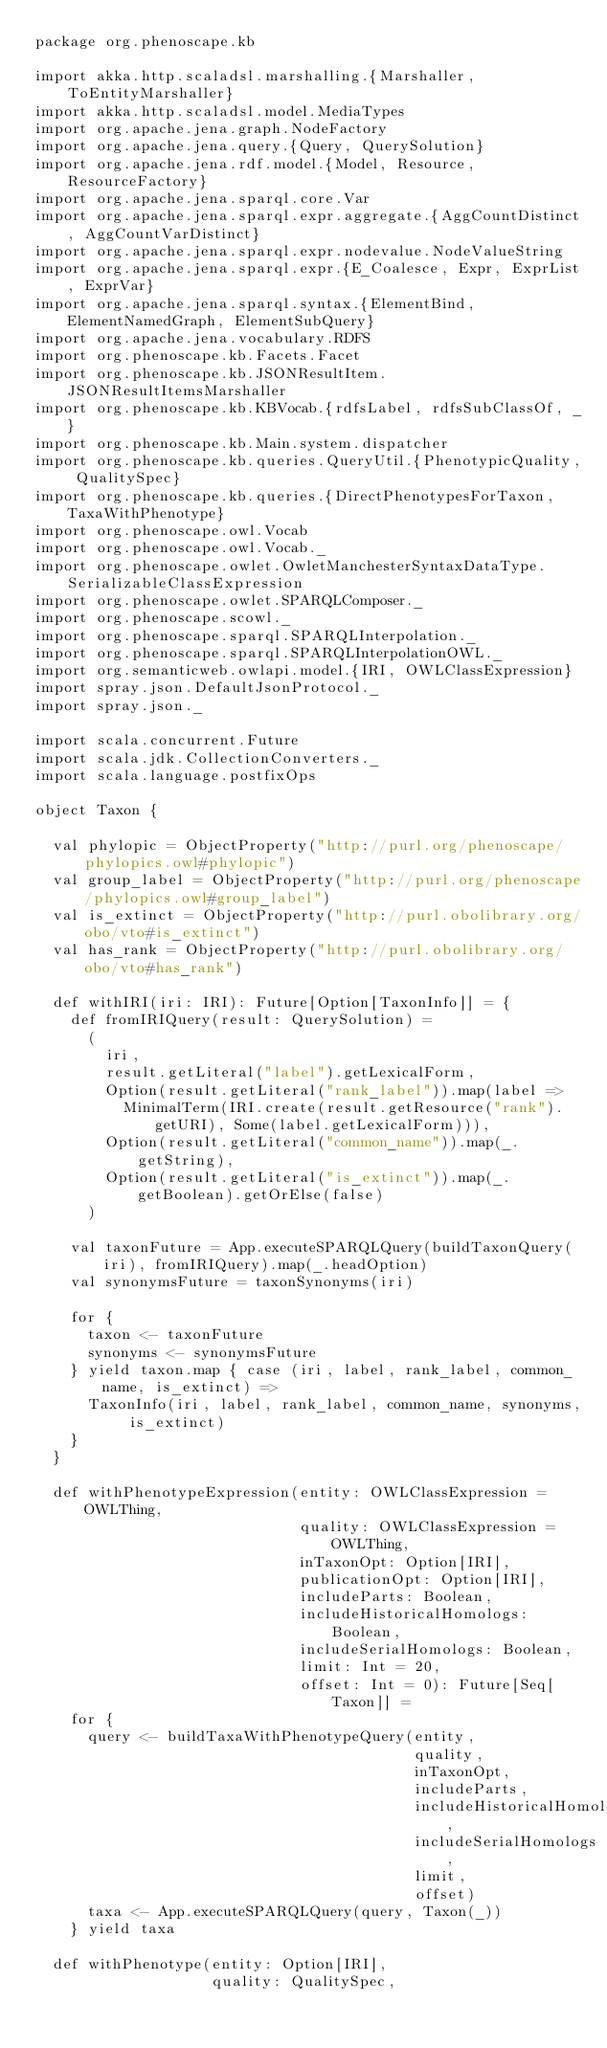<code> <loc_0><loc_0><loc_500><loc_500><_Scala_>package org.phenoscape.kb

import akka.http.scaladsl.marshalling.{Marshaller, ToEntityMarshaller}
import akka.http.scaladsl.model.MediaTypes
import org.apache.jena.graph.NodeFactory
import org.apache.jena.query.{Query, QuerySolution}
import org.apache.jena.rdf.model.{Model, Resource, ResourceFactory}
import org.apache.jena.sparql.core.Var
import org.apache.jena.sparql.expr.aggregate.{AggCountDistinct, AggCountVarDistinct}
import org.apache.jena.sparql.expr.nodevalue.NodeValueString
import org.apache.jena.sparql.expr.{E_Coalesce, Expr, ExprList, ExprVar}
import org.apache.jena.sparql.syntax.{ElementBind, ElementNamedGraph, ElementSubQuery}
import org.apache.jena.vocabulary.RDFS
import org.phenoscape.kb.Facets.Facet
import org.phenoscape.kb.JSONResultItem.JSONResultItemsMarshaller
import org.phenoscape.kb.KBVocab.{rdfsLabel, rdfsSubClassOf, _}
import org.phenoscape.kb.Main.system.dispatcher
import org.phenoscape.kb.queries.QueryUtil.{PhenotypicQuality, QualitySpec}
import org.phenoscape.kb.queries.{DirectPhenotypesForTaxon, TaxaWithPhenotype}
import org.phenoscape.owl.Vocab
import org.phenoscape.owl.Vocab._
import org.phenoscape.owlet.OwletManchesterSyntaxDataType.SerializableClassExpression
import org.phenoscape.owlet.SPARQLComposer._
import org.phenoscape.scowl._
import org.phenoscape.sparql.SPARQLInterpolation._
import org.phenoscape.sparql.SPARQLInterpolationOWL._
import org.semanticweb.owlapi.model.{IRI, OWLClassExpression}
import spray.json.DefaultJsonProtocol._
import spray.json._

import scala.concurrent.Future
import scala.jdk.CollectionConverters._
import scala.language.postfixOps

object Taxon {

  val phylopic = ObjectProperty("http://purl.org/phenoscape/phylopics.owl#phylopic")
  val group_label = ObjectProperty("http://purl.org/phenoscape/phylopics.owl#group_label")
  val is_extinct = ObjectProperty("http://purl.obolibrary.org/obo/vto#is_extinct")
  val has_rank = ObjectProperty("http://purl.obolibrary.org/obo/vto#has_rank")

  def withIRI(iri: IRI): Future[Option[TaxonInfo]] = {
    def fromIRIQuery(result: QuerySolution) =
      (
        iri,
        result.getLiteral("label").getLexicalForm,
        Option(result.getLiteral("rank_label")).map(label =>
          MinimalTerm(IRI.create(result.getResource("rank").getURI), Some(label.getLexicalForm))),
        Option(result.getLiteral("common_name")).map(_.getString),
        Option(result.getLiteral("is_extinct")).map(_.getBoolean).getOrElse(false)
      )

    val taxonFuture = App.executeSPARQLQuery(buildTaxonQuery(iri), fromIRIQuery).map(_.headOption)
    val synonymsFuture = taxonSynonyms(iri)

    for {
      taxon <- taxonFuture
      synonyms <- synonymsFuture
    } yield taxon.map { case (iri, label, rank_label, common_name, is_extinct) =>
      TaxonInfo(iri, label, rank_label, common_name, synonyms, is_extinct)
    }
  }

  def withPhenotypeExpression(entity: OWLClassExpression = OWLThing,
                              quality: OWLClassExpression = OWLThing,
                              inTaxonOpt: Option[IRI],
                              publicationOpt: Option[IRI],
                              includeParts: Boolean,
                              includeHistoricalHomologs: Boolean,
                              includeSerialHomologs: Boolean,
                              limit: Int = 20,
                              offset: Int = 0): Future[Seq[Taxon]] =
    for {
      query <- buildTaxaWithPhenotypeQuery(entity,
                                           quality,
                                           inTaxonOpt,
                                           includeParts,
                                           includeHistoricalHomologs,
                                           includeSerialHomologs,
                                           limit,
                                           offset)
      taxa <- App.executeSPARQLQuery(query, Taxon(_))
    } yield taxa

  def withPhenotype(entity: Option[IRI],
                    quality: QualitySpec,</code> 